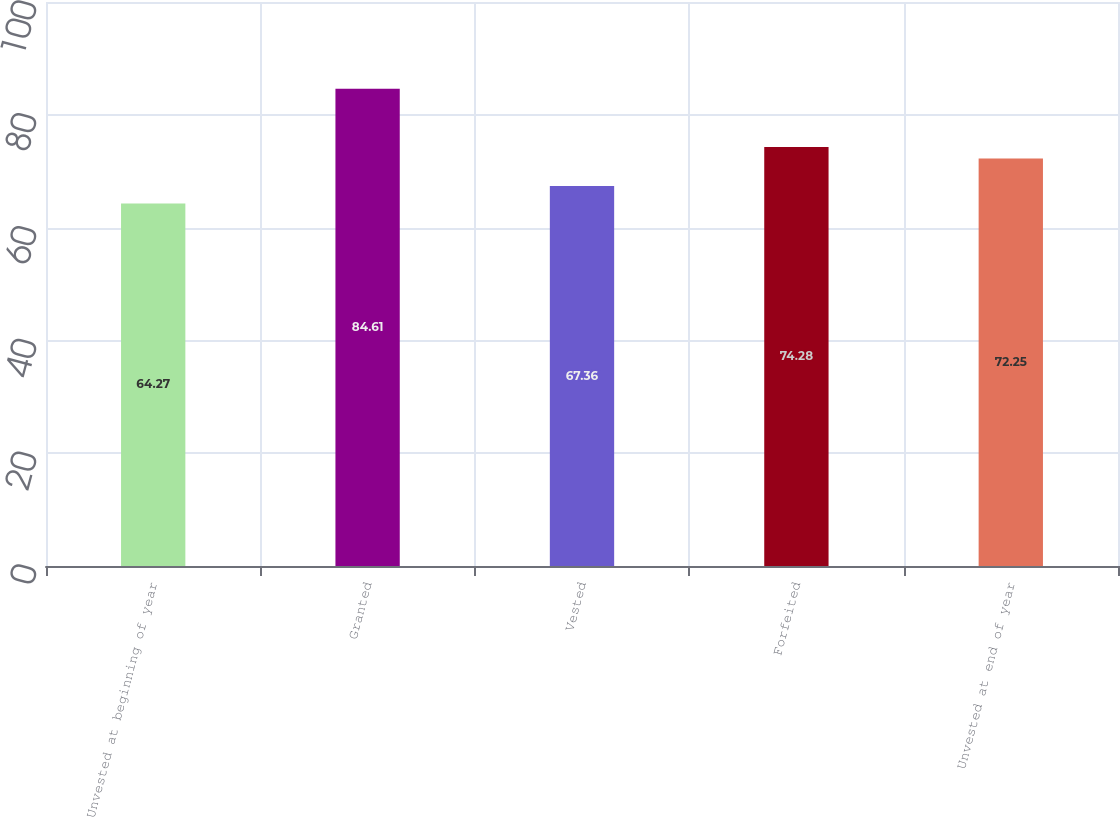Convert chart. <chart><loc_0><loc_0><loc_500><loc_500><bar_chart><fcel>Unvested at beginning of year<fcel>Granted<fcel>Vested<fcel>Forfeited<fcel>Unvested at end of year<nl><fcel>64.27<fcel>84.61<fcel>67.36<fcel>74.28<fcel>72.25<nl></chart> 